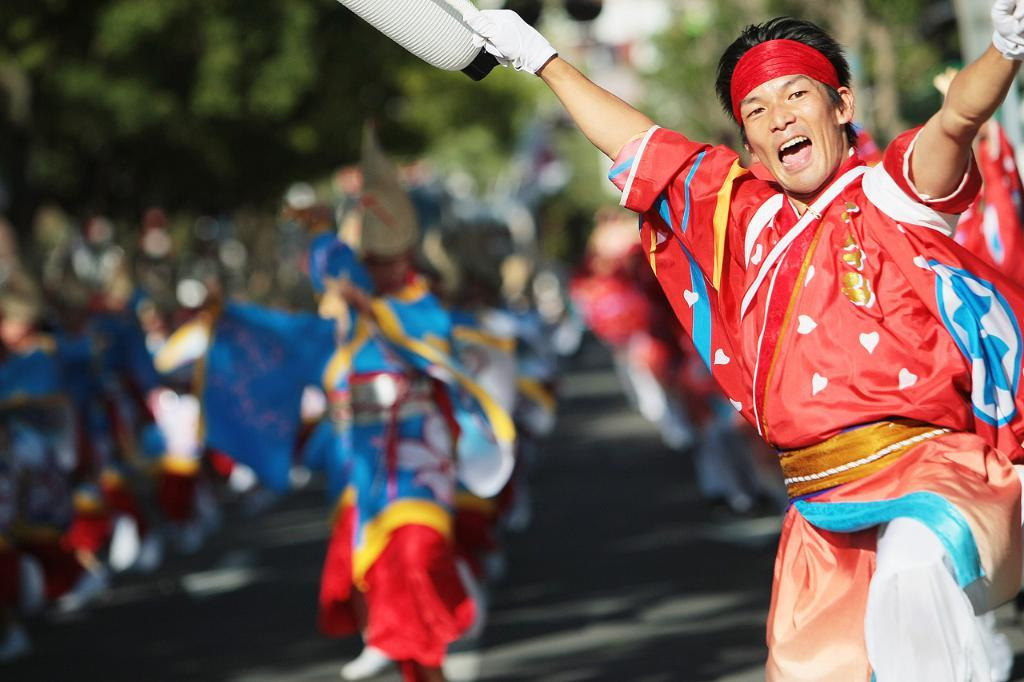What is happening in the foreground of the picture? There is a person in the foreground of the picture, and they are dancing with a cheerful face. What is the person holding in the image? The person is holding an object in the image. Can you describe the background of the image? The background of the image is blurred, and there are people and greenery visible. What type of bun is being used as a prop in the image? There is no bun present in the image; the person is holding an unspecified object. Can you tell me how many fruits are visible in the image? There are no fruits visible in the image. 